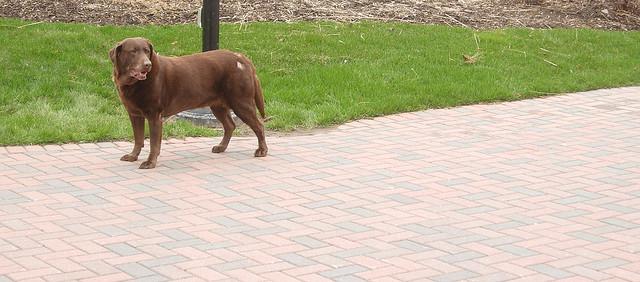Is the dog waiting for someone?
Write a very short answer. Yes. What is the dog standing on?
Write a very short answer. Bricks. Is it abnormal for this animal to be on the sidewalk?
Concise answer only. No. Is the dog standing in the grass?
Write a very short answer. No. Does this look like an animal a person would want to pet?
Short answer required. Yes. 